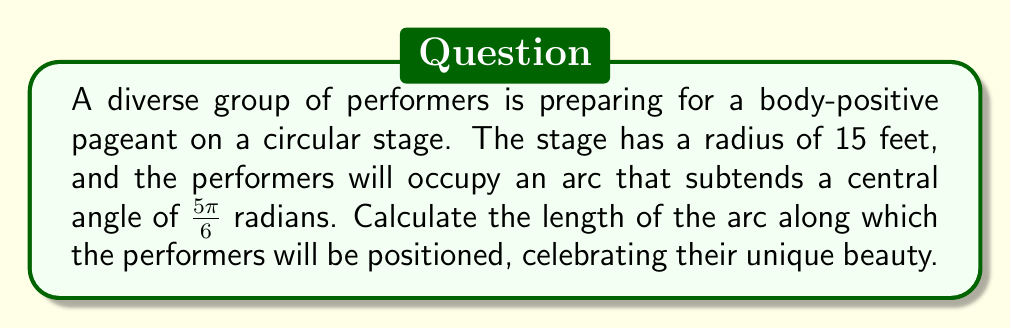Solve this math problem. Let's approach this step-by-step:

1) The formula for arc length is:
   $s = r\theta$
   Where:
   $s$ is the arc length
   $r$ is the radius of the circle
   $\theta$ is the central angle in radians

2) We are given:
   $r = 15$ feet
   $\theta = \frac{5\pi}{6}$ radians

3) Let's substitute these values into our formula:
   $s = 15 \cdot \frac{5\pi}{6}$

4) Simplify:
   $s = \frac{75\pi}{6}$

5) To get a decimal approximation:
   $s \approx 39.27$ feet

[asy]
unitsize(10);
draw(circle((0,0),1.5), rgb(0,0,1));
draw((0,0)--(1.5,0), rgb(0.7,0.7,0.7));
draw((0,0)--(-1.299,-0.75), rgb(0.7,0.7,0.7));
draw(arc((0,0),1.5,0,150), rgb(1,0,0), Arrows);
label("15 ft", (0.75,0), S);
label("$\frac{5\pi}{6}$", (0.5,-0.3));
[/asy]

This arc length represents the space where the diverse group of performers will stand, showcasing their unique beauty and promoting body positivity.
Answer: $\frac{75\pi}{6}$ feet or approximately 39.27 feet 